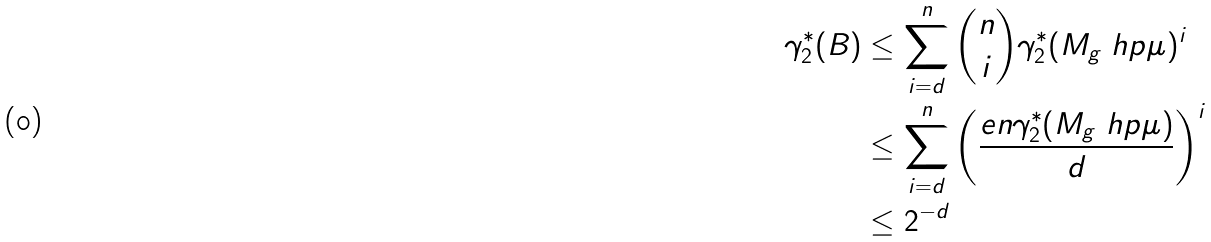<formula> <loc_0><loc_0><loc_500><loc_500>\gamma _ { 2 } ^ { * } ( B ) & \leq \sum _ { i = d } ^ { n } { n \choose i } \gamma _ { 2 } ^ { * } ( M _ { g } \ h p \mu ) ^ { i } \\ & \leq \sum _ { i = d } ^ { n } \left ( \frac { e n \gamma _ { 2 } ^ { * } ( M _ { g } \ h p \mu ) } { d } \right ) ^ { i } \\ & \leq 2 ^ { - d }</formula> 